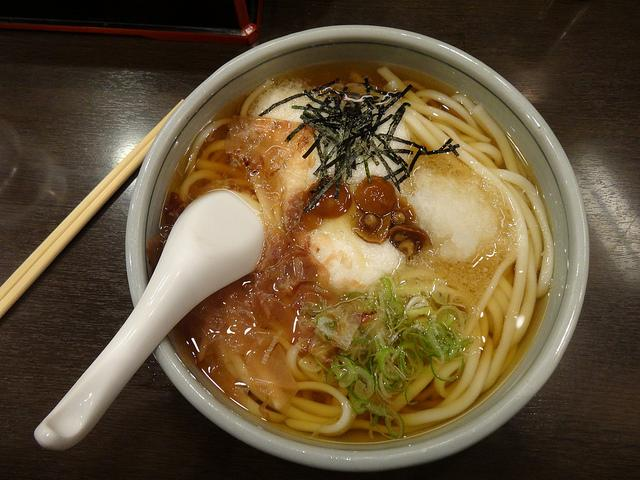What is the bowl made from?

Choices:
A) wood
B) steel
C) plastic
D) glass glass 